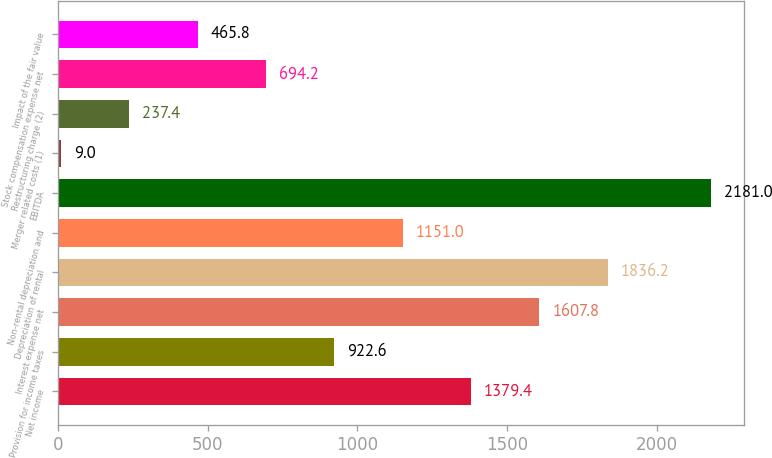Convert chart. <chart><loc_0><loc_0><loc_500><loc_500><bar_chart><fcel>Net income<fcel>Provision for income taxes<fcel>Interest expense net<fcel>Depreciation of rental<fcel>Non-rental depreciation and<fcel>EBITDA<fcel>Merger related costs (1)<fcel>Restructuring charge (2)<fcel>Stock compensation expense net<fcel>Impact of the fair value<nl><fcel>1379.4<fcel>922.6<fcel>1607.8<fcel>1836.2<fcel>1151<fcel>2181<fcel>9<fcel>237.4<fcel>694.2<fcel>465.8<nl></chart> 